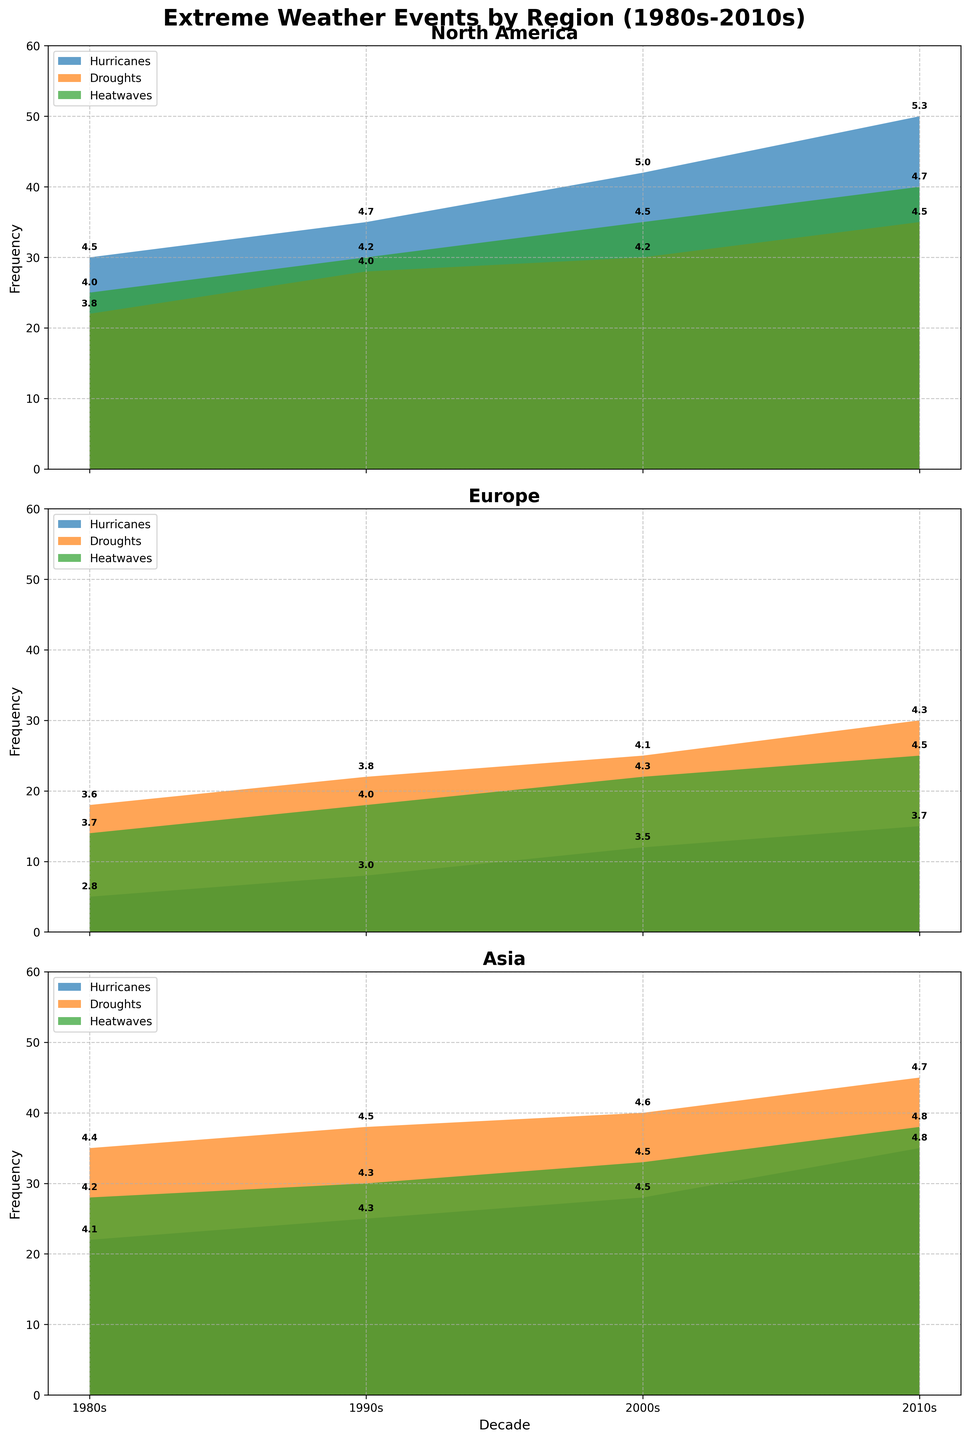How many types of extreme weather events are displayed on the plots? There are three types of extreme weather events displayed in the area charts: Hurricanes, Droughts, and Heatwaves.
Answer: 3 What is the overall trend of hurricanes in North America from the 1980s to the 2010s? The frequency of hurricanes in North America shows a clear increasing trend from 30 in the 1980s to 50 in the 2010s.
Answer: Increasing Which region had the highest recorded frequency of droughts in the 2010s? In the 2010s, Asia recorded the highest frequency of droughts with a value of 45.
Answer: Asia What is the average intensity of heatwaves in Europe across all decades? The intensities of heatwaves in Europe are 3.7 (1980s), 4.0 (1990s), 4.3 (2000s), and 4.5 (2010s). The average intensity is (3.7 + 4.0 + 4.3 + 4.5) / 4 = 4.125.
Answer: 4.1 (rounded) Which decade saw the highest frequency of heatwaves in Asia? The 2010s saw the highest frequency of heatwaves in Asia with a value of 38.
Answer: 2010s Compare the trend of droughts between North America and Europe from the 1980s to the 2010s. North America saw the frequency of droughts increase from 22 to 35 from the 1980s to the 2010s, while in Europe, the frequency increased from 18 to 30 over the same period. Both regions show an increasing trend.
Answer: Both regions show an increasing trend Did any region see a decrease in the frequency of hurricanes over any of the decades? None of the regions (North America, Europe, Asia) show a decrease in the frequency of hurricanes over any of the decades from the 1980s to 2010s.
Answer: No What annotates the data points in each subplot specifically? The data points in each subplot are annotated with the intensity values of the respective extreme weather events.
Answer: Intensity values 